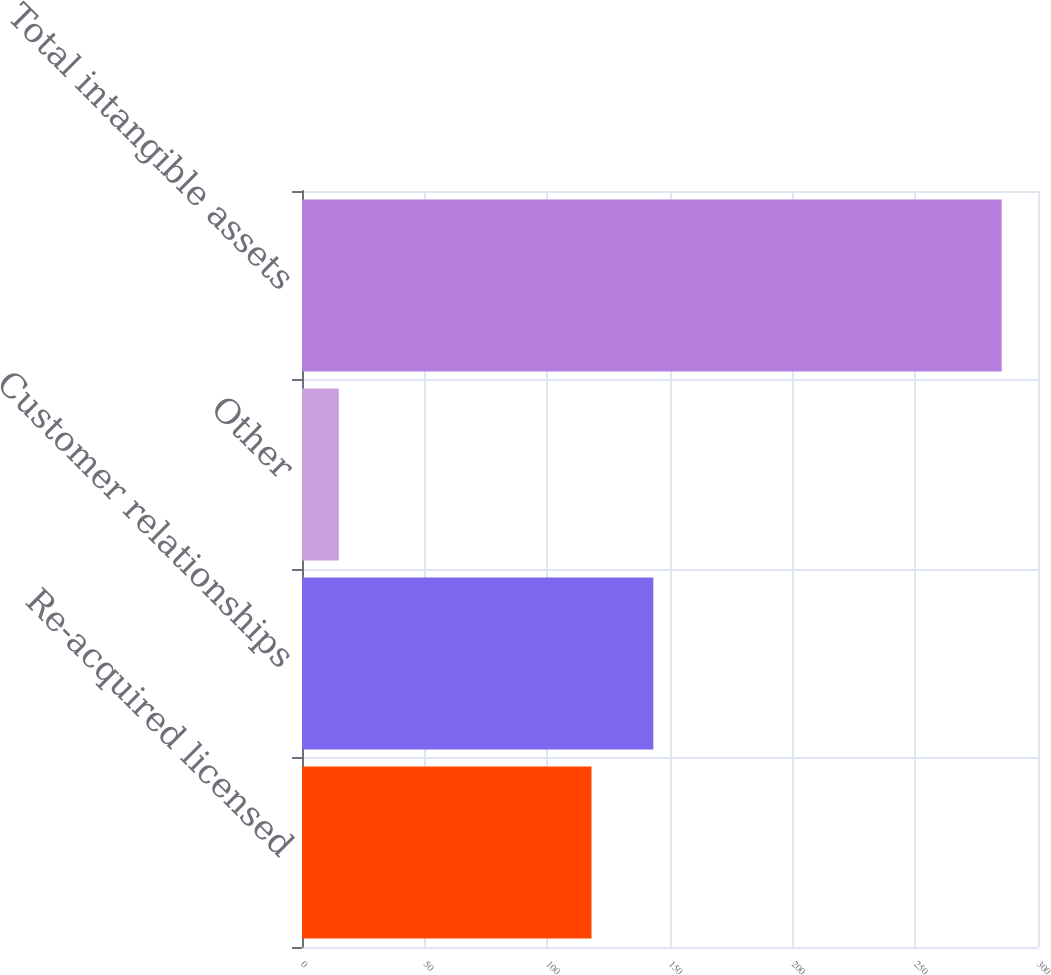Convert chart. <chart><loc_0><loc_0><loc_500><loc_500><bar_chart><fcel>Re-acquired licensed<fcel>Customer relationships<fcel>Other<fcel>Total intangible assets<nl><fcel>118<fcel>143.2<fcel>15<fcel>285.2<nl></chart> 